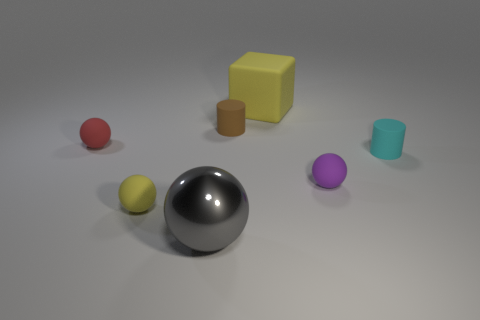What number of other objects are the same material as the large yellow object?
Make the answer very short. 5. Is the yellow thing in front of the small brown object made of the same material as the small object to the right of the small purple object?
Offer a terse response. Yes. There is a purple object that is made of the same material as the small red sphere; what is its shape?
Make the answer very short. Sphere. Are there any other things that are the same color as the block?
Ensure brevity in your answer.  Yes. What number of big blue rubber objects are there?
Provide a succinct answer. 0. What is the shape of the tiny matte object that is both on the left side of the large yellow rubber object and on the right side of the small yellow thing?
Make the answer very short. Cylinder. What shape is the big object that is behind the small thing to the right of the ball to the right of the small brown matte cylinder?
Your answer should be very brief. Cube. What is the thing that is behind the tiny cyan object and in front of the tiny brown matte thing made of?
Keep it short and to the point. Rubber. How many matte blocks have the same size as the gray thing?
Your answer should be compact. 1. What number of metal things are either small brown cylinders or purple cylinders?
Give a very brief answer. 0. 